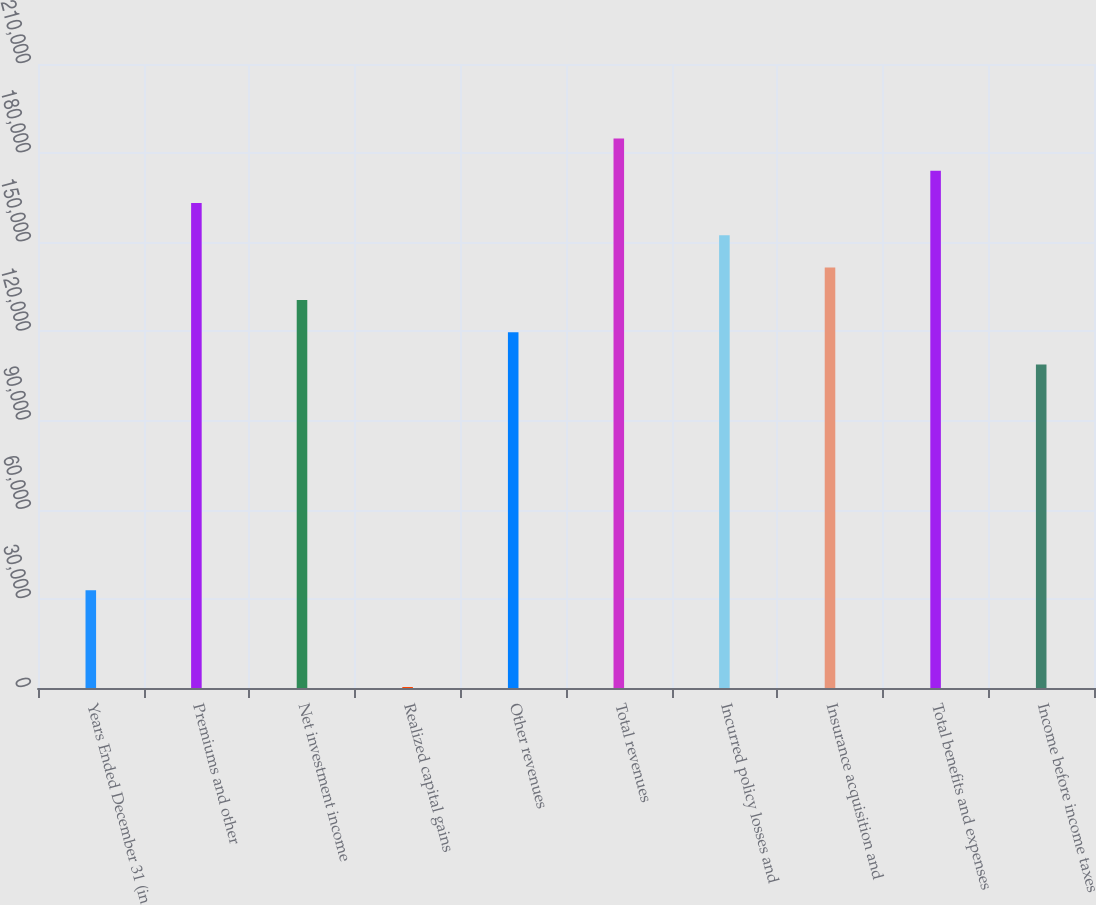Convert chart to OTSL. <chart><loc_0><loc_0><loc_500><loc_500><bar_chart><fcel>Years Ended December 31 (in<fcel>Premiums and other<fcel>Net investment income<fcel>Realized capital gains<fcel>Other revenues<fcel>Total revenues<fcel>Incurred policy losses and<fcel>Insurance acquisition and<fcel>Total benefits and expenses<fcel>Income before income taxes<nl><fcel>32910.2<fcel>163187<fcel>130618<fcel>341<fcel>119761<fcel>184900<fcel>152331<fcel>141474<fcel>174043<fcel>108905<nl></chart> 